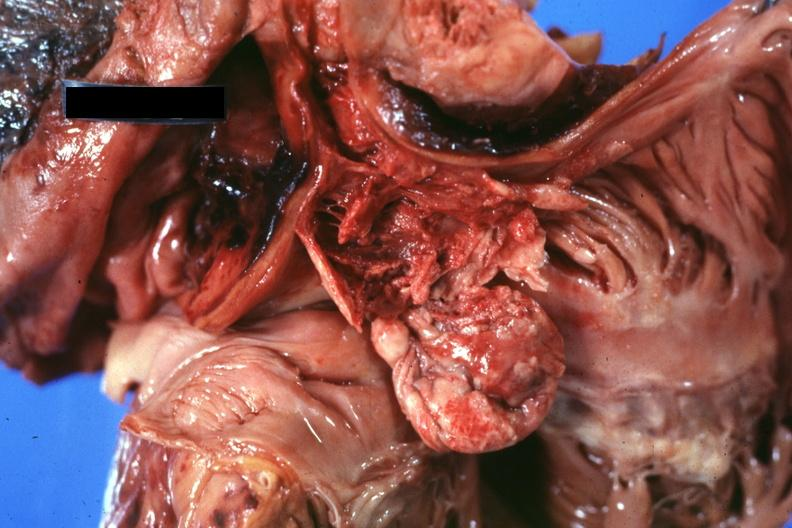s mucinous cystadenocarcinoma present?
Answer the question using a single word or phrase. No 